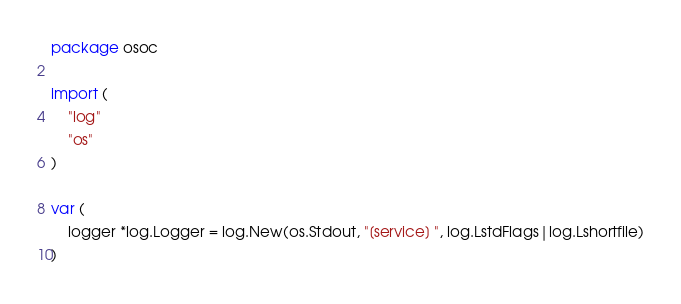Convert code to text. <code><loc_0><loc_0><loc_500><loc_500><_Go_>package osoc

import (
	"log"
	"os"
)

var (
	logger *log.Logger = log.New(os.Stdout, "[service] ", log.LstdFlags|log.Lshortfile)
)
</code> 